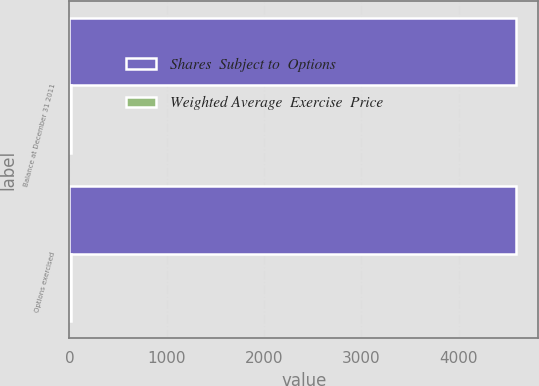Convert chart. <chart><loc_0><loc_0><loc_500><loc_500><stacked_bar_chart><ecel><fcel>Balance at December 31 2011<fcel>Options exercised<nl><fcel>Shares  Subject to  Options<fcel>4590<fcel>4590<nl><fcel>Weighted Average  Exercise  Price<fcel>12.48<fcel>12.48<nl></chart> 